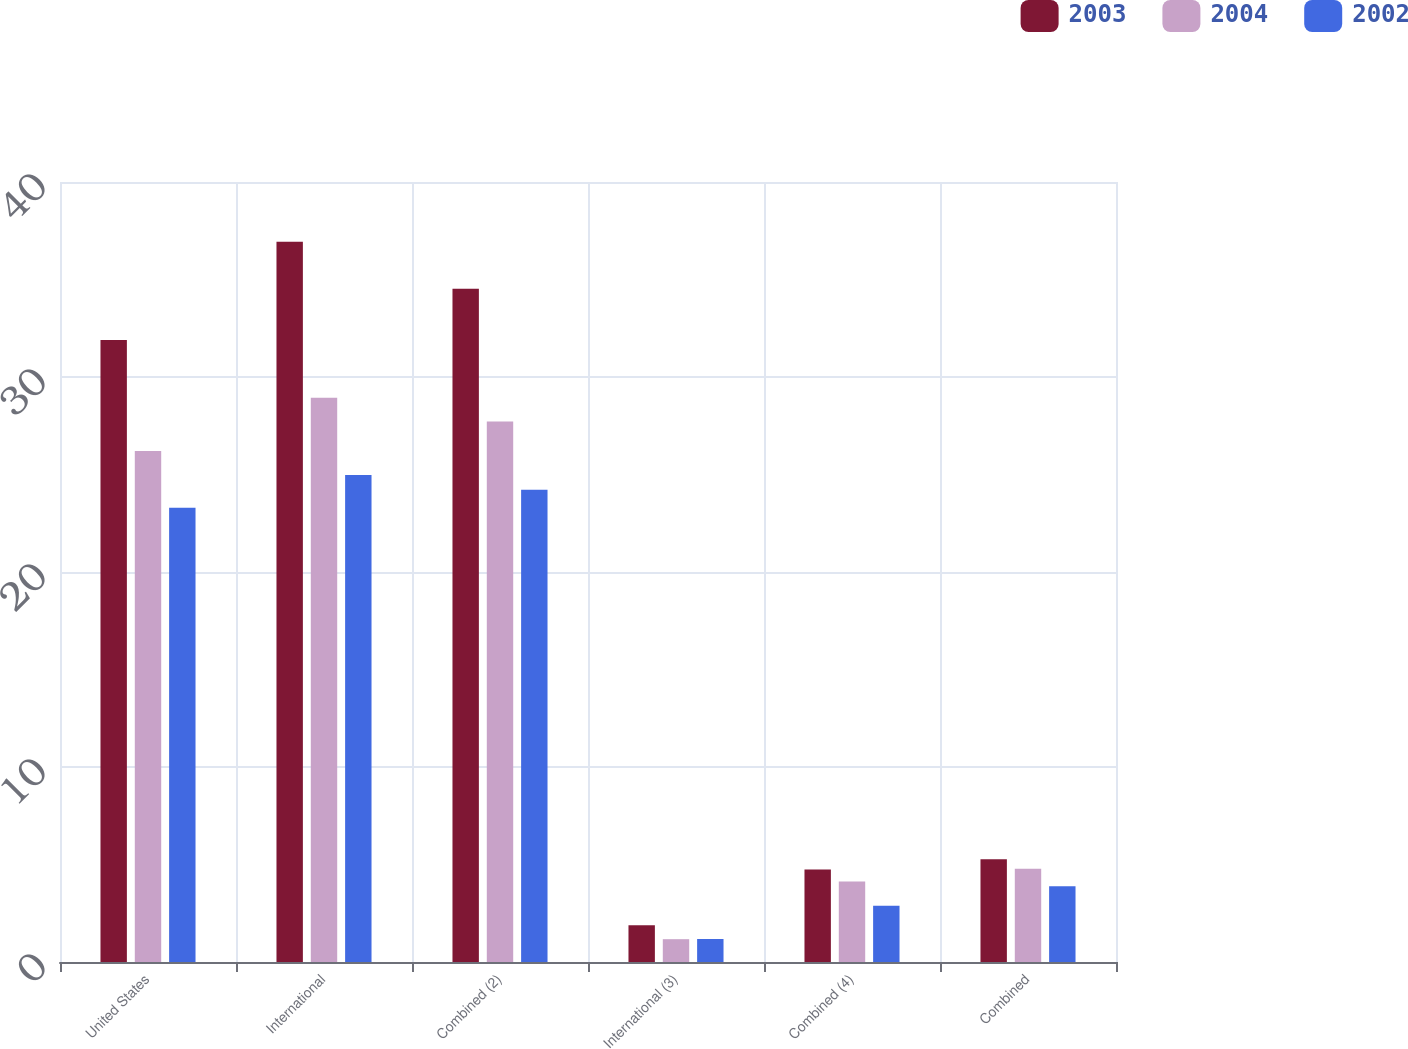Convert chart. <chart><loc_0><loc_0><loc_500><loc_500><stacked_bar_chart><ecel><fcel>United States<fcel>International<fcel>Combined (2)<fcel>International (3)<fcel>Combined (4)<fcel>Combined<nl><fcel>2003<fcel>31.9<fcel>36.94<fcel>34.53<fcel>1.88<fcel>4.74<fcel>5.27<nl><fcel>2004<fcel>26.21<fcel>28.94<fcel>27.72<fcel>1.17<fcel>4.13<fcel>4.78<nl><fcel>2002<fcel>23.29<fcel>24.98<fcel>24.22<fcel>1.18<fcel>2.89<fcel>3.88<nl></chart> 